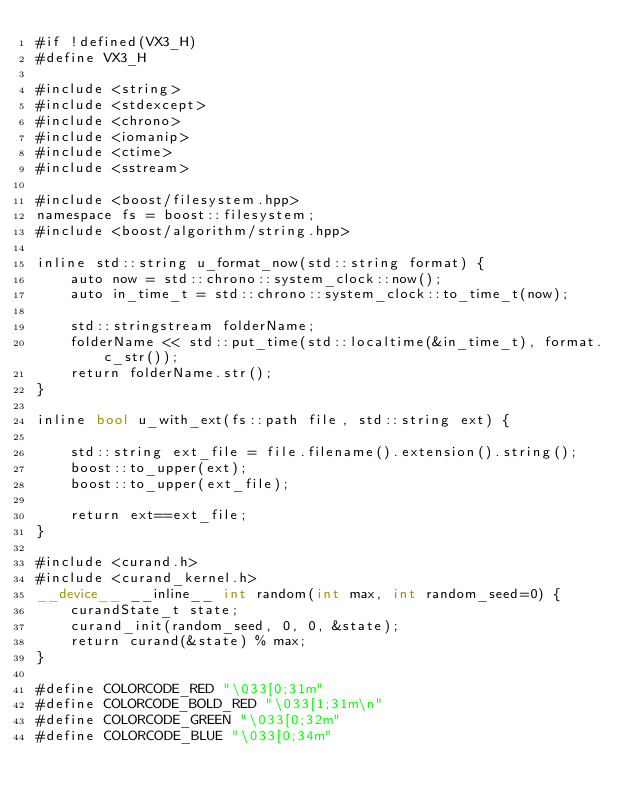Convert code to text. <code><loc_0><loc_0><loc_500><loc_500><_Cuda_>#if !defined(VX3_H)
#define VX3_H

#include <string>
#include <stdexcept>
#include <chrono>
#include <iomanip>
#include <ctime>
#include <sstream>

#include <boost/filesystem.hpp>
namespace fs = boost::filesystem;
#include <boost/algorithm/string.hpp>

inline std::string u_format_now(std::string format) {
    auto now = std::chrono::system_clock::now();
    auto in_time_t = std::chrono::system_clock::to_time_t(now);

    std::stringstream folderName;
    folderName << std::put_time(std::localtime(&in_time_t), format.c_str());
    return folderName.str();
}

inline bool u_with_ext(fs::path file, std::string ext) {

    std::string ext_file = file.filename().extension().string();
    boost::to_upper(ext);
    boost::to_upper(ext_file);

    return ext==ext_file;
}

#include <curand.h>
#include <curand_kernel.h>
__device__ __inline__ int random(int max, int random_seed=0) {
    curandState_t state;
    curand_init(random_seed, 0, 0, &state);
    return curand(&state) % max;
}

#define COLORCODE_RED "\033[0;31m" 
#define COLORCODE_BOLD_RED "\033[1;31m\n" 
#define COLORCODE_GREEN "\033[0;32m" 
#define COLORCODE_BLUE "\033[0;34m" </code> 